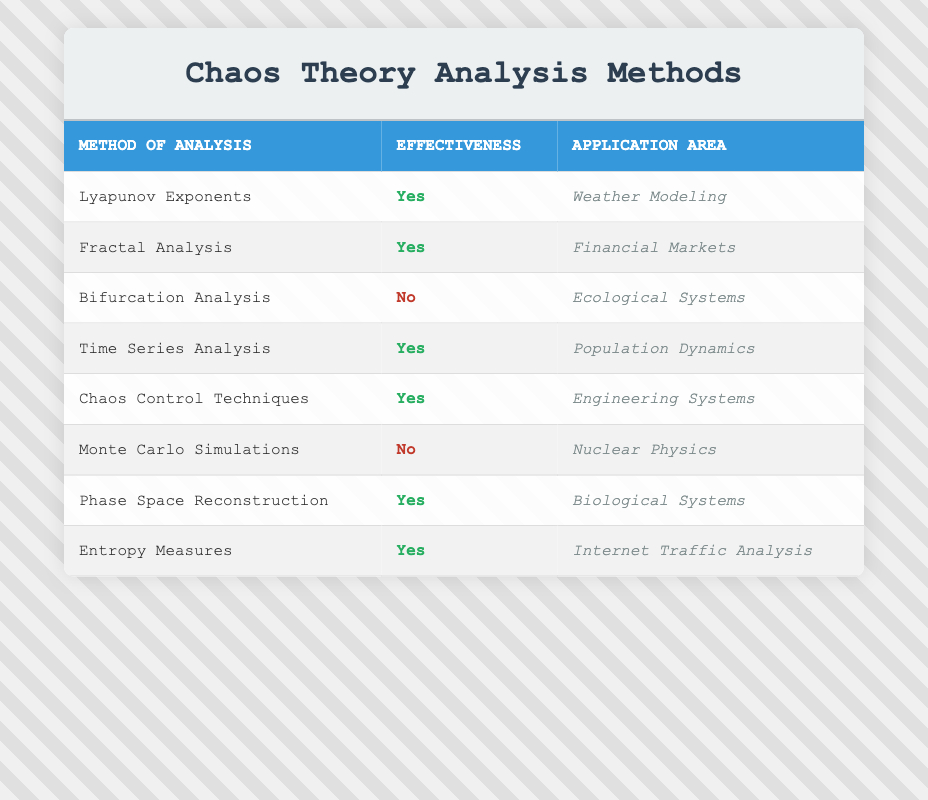What methods of analysis are effective in biological systems? From the table, the method listed under the application area of 'Biological Systems' is 'Phase Space Reconstruction', which is marked as effective.
Answer: Phase Space Reconstruction Which analysis method is not effective in nuclear physics? The table shows that 'Monte Carlo Simulations' is the method listed under nuclear physics and it is marked as not effective.
Answer: Monte Carlo Simulations How many methods of analysis are effective? By counting the rows in the table where the effectiveness is marked as 'Yes', we find that there are 5 methods that are effective: Lyapunov Exponents, Fractal Analysis, Time Series Analysis, Chaos Control Techniques, Phase Space Reconstruction, and Entropy Measures. Thus, the total is 5.
Answer: 5 Is there a method of analysis that is effective in weather modeling? From the table, 'Lyapunov Exponents' is listed under 'Weather Modeling' and is marked as effective, indicating that this method works well in this area.
Answer: Yes What is the difference between the number of effective and not effective methods? Counting the effective methods yields 5, while the not effective methods are 'Bifurcation Analysis' and 'Monte Carlo Simulations', giving a total of 2. The difference is calculated as 5 (effective) - 2 (not effective) = 3.
Answer: 3 Which application area has the most effective analysis methods? By examining the table, we can identify the application areas and tally the number of effective methods. The application areas are: Weather Modeling (1), Financial Markets (1), Population Dynamics (1), Engineering Systems (1), Biological Systems (1), and Internet Traffic Analysis (1). All areas have only one method listed as effective, indicating an equal distribution.
Answer: No area stands out Are any analysis methods effective in both ecological systems and nuclear physics? Looking at the table, 'Bifurcation Analysis' is marked as not effective in ecological systems, and 'Monte Carlo Simulations' is also not effective in nuclear physics. Therefore, there are no methods that are effective in both areas.
Answer: No What is the relationship between effectivity and application area in time series analysis? In the table, 'Time Series Analysis' is marked effective and is used in the application area of 'Population Dynamics', highlighting a positive relationship between this method and its effectiveness in this specific context.
Answer: Effective in Population Dynamics 